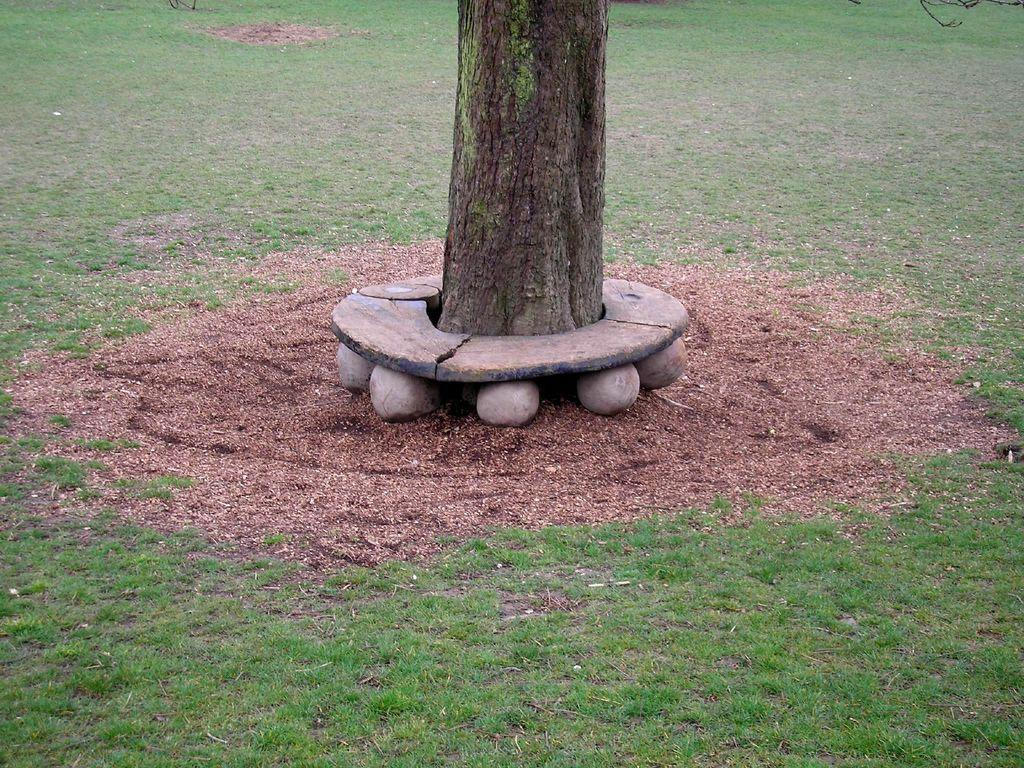What is the main feature of the image? The main feature of the image is an open grass ground. Are there any objects or structures on the grass ground? Yes, there are stones and a tree trunk in the centre of the grass ground. How many ladybugs can be seen on the tree trunk in the image? There are no ladybugs visible on the tree trunk in the image. Are there any bears present in the image? There are no bears present in the image. 